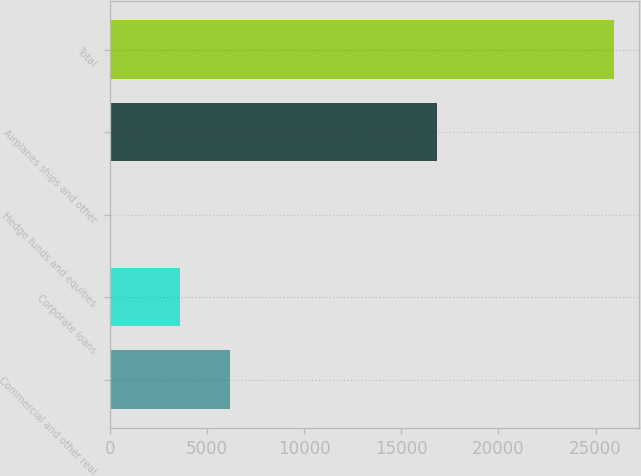Convert chart. <chart><loc_0><loc_0><loc_500><loc_500><bar_chart><fcel>Commercial and other real<fcel>Corporate loans<fcel>Hedge funds and equities<fcel>Airplanes ships and other<fcel>Total<nl><fcel>6175.1<fcel>3587<fcel>58<fcel>16849<fcel>25939<nl></chart> 